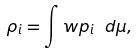<formula> <loc_0><loc_0><loc_500><loc_500>\rho _ { i } = \int w p _ { i } \ d \mu ,</formula> 